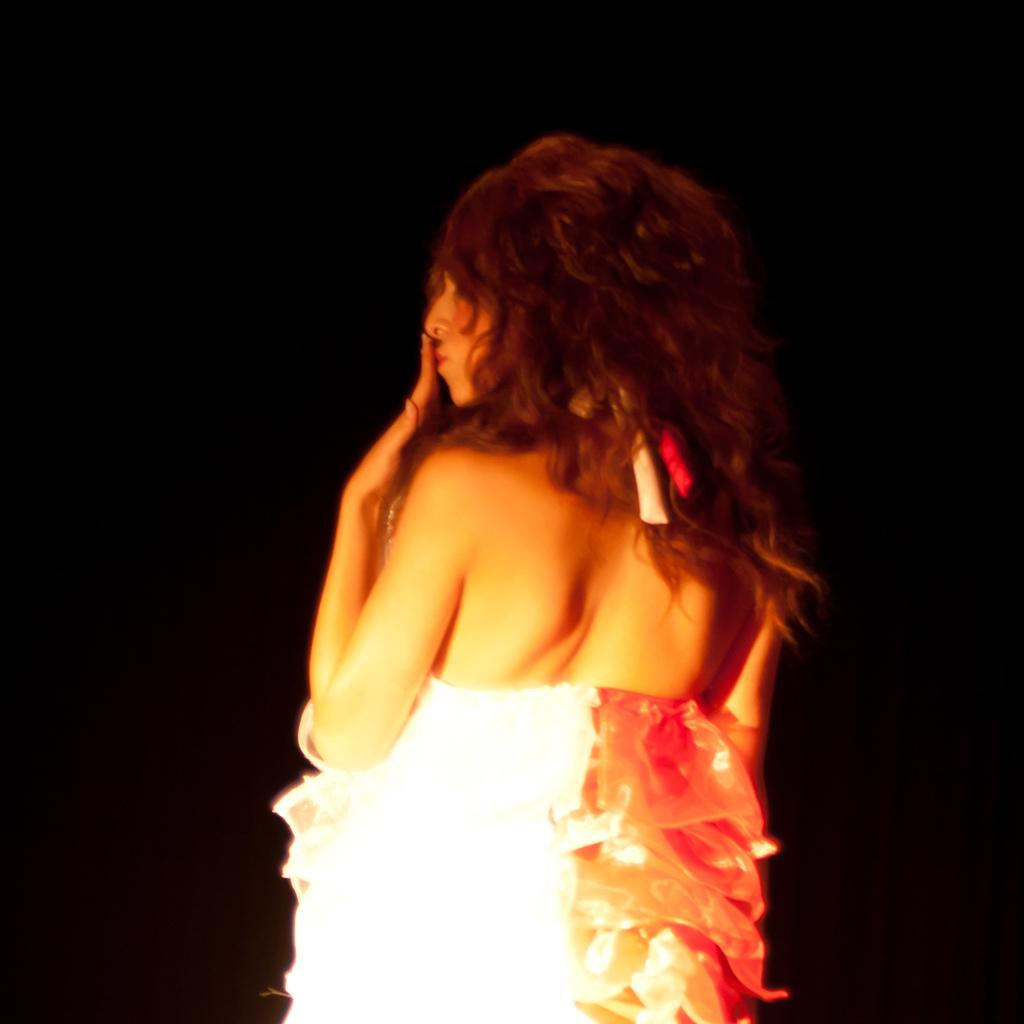Who is the main subject in the image? There is a woman in the image. What is the woman wearing? The woman is wearing a white dress. What is the woman doing in the image? The woman is standing. What color is the background of the image? The background of the image is black. How many cows can be seen in the image? There are no cows present in the image. What type of vein is visible on the woman's arm in the image? There is no visible vein on the woman's arm in the image, nor is there any indication that her arm is visible. 